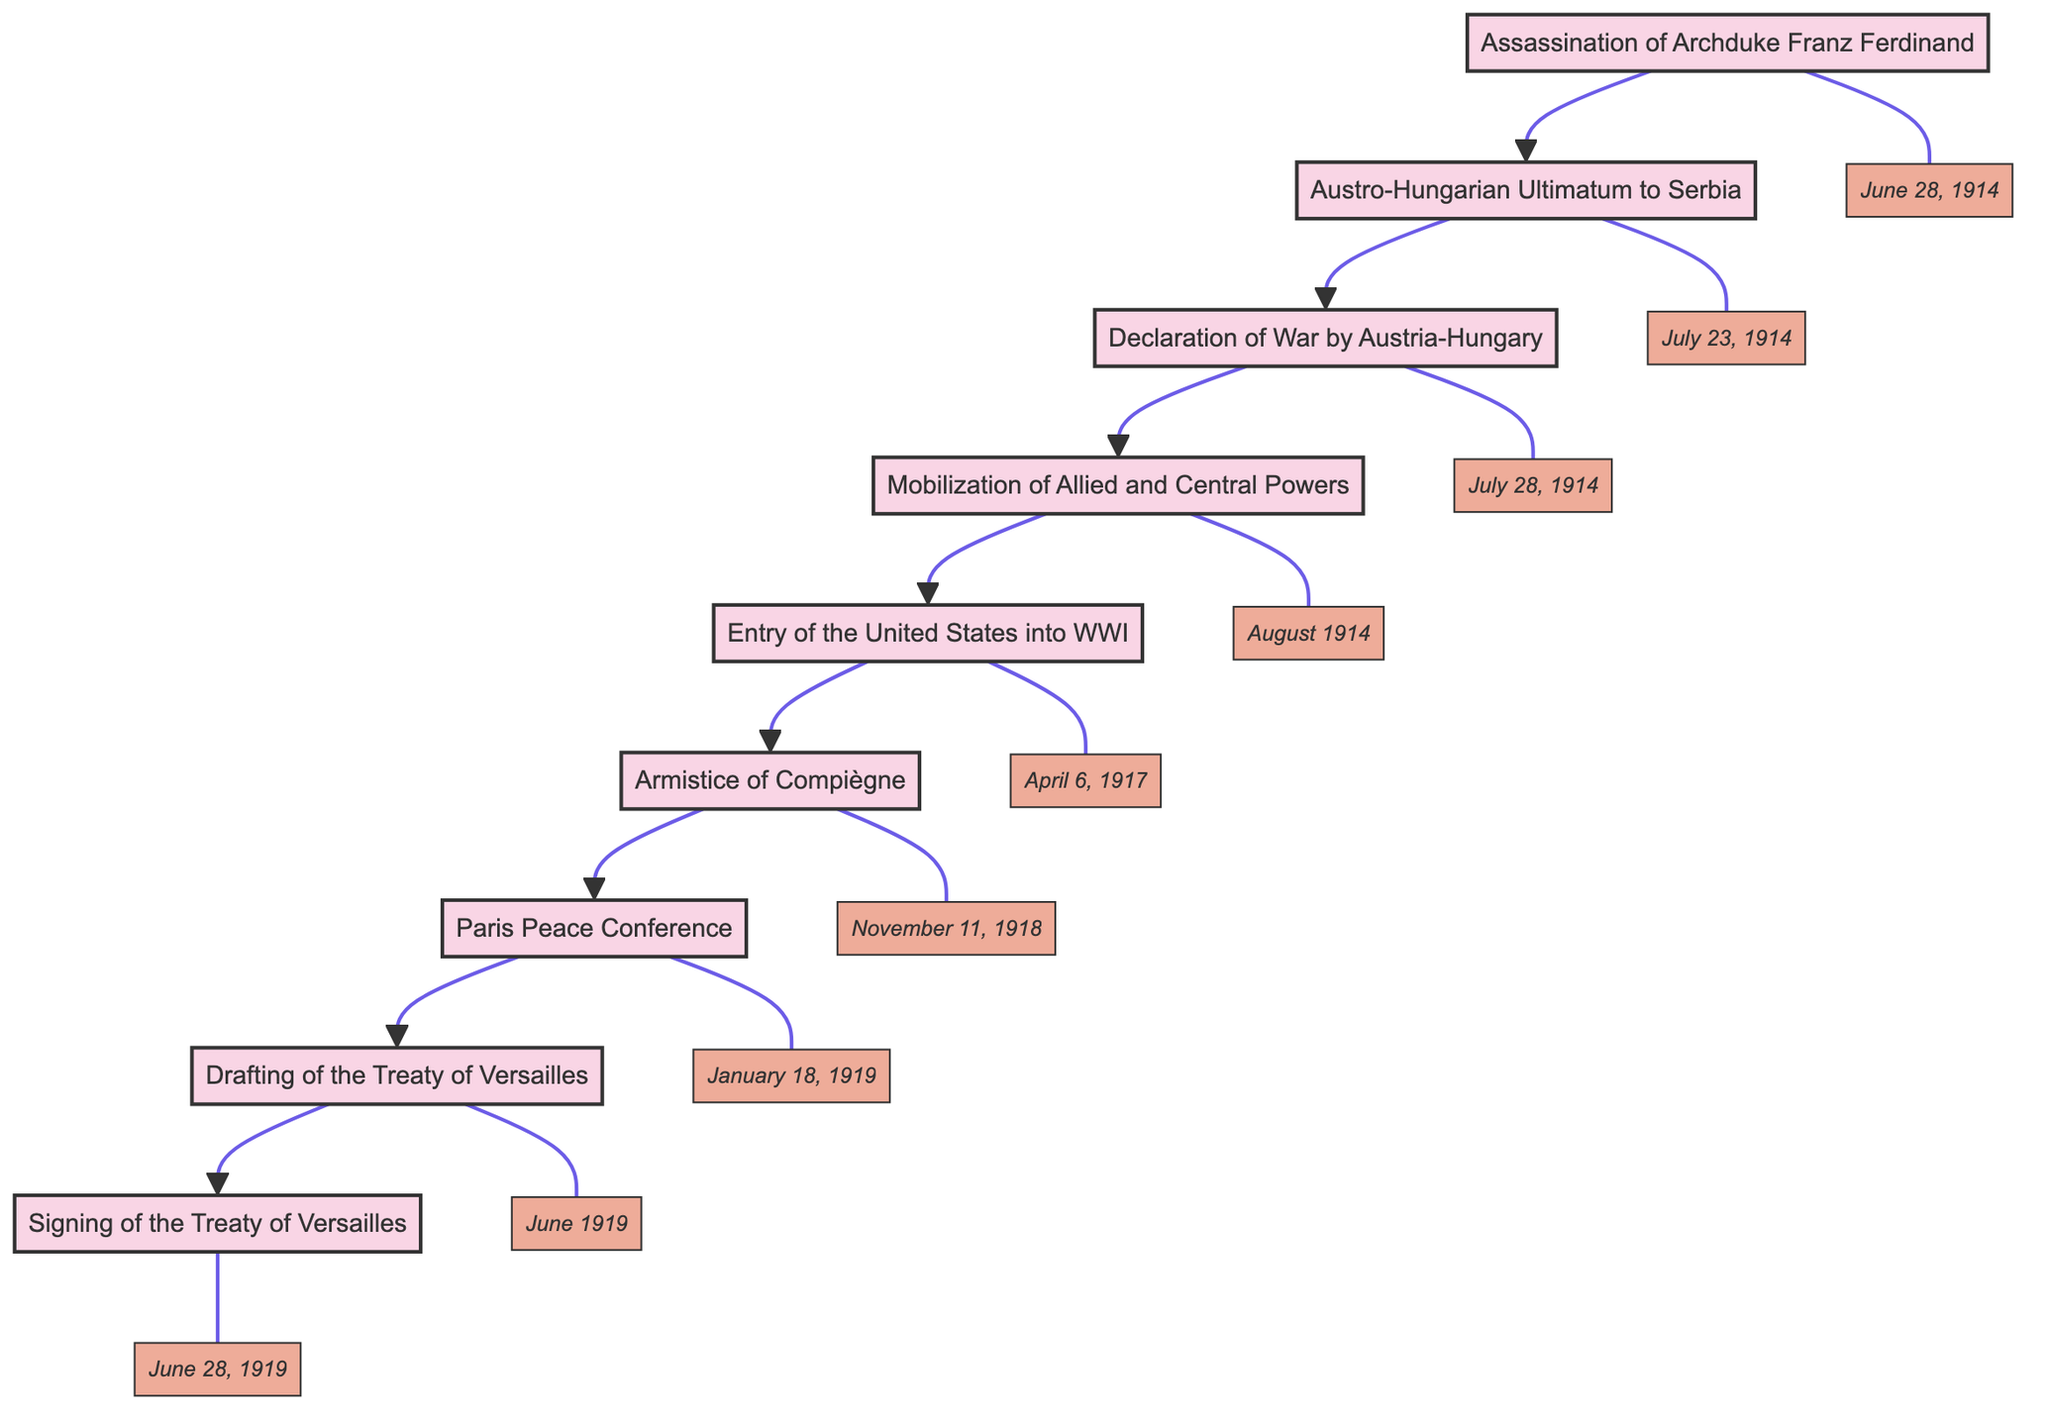What event triggers the Austro-Hungarian Ultimatum to Serbia? The diagram indicates that the event leading to the Austro-Hungarian Ultimatum is the "Assassination of Archduke Franz Ferdinand" which occurs on June 28, 1914. This event is the initial spark that escalates tensions.
Answer: Assassination of Archduke Franz Ferdinand What date marks the Signing of the Treaty of Versailles? According to the diagram, the Signing of the Treaty of Versailles takes place on June 28, 1919. It is indicated as the last event in the sequence and its specific date is listed.
Answer: June 28, 1919 How many major nodes are in the flowchart? By counting each unique event in the flowchart, we find that there are a total of 9 major nodes. These include all significant events leading up to the Treaty of Versailles.
Answer: 9 What event follows the Armistice of Compiègne? The flowchart shows that after the "Armistice of Compiègne" on November 11, 1918, the next event is the "Paris Peace Conference," which commences on January 18, 1919.
Answer: Paris Peace Conference Which event marks the United States’ involvement in World War I? The diagram specifies that the "Entry of the United States into WWI" occurs on April 6, 1917. This is highlighted as a significant turning point in the war where the US joins the Allies.
Answer: Entry of the United States into WWI What is the main focus of the Drafting of the Treaty of Versailles? The flowchart states that the primary objective during the "Drafting of the Treaty of Versailles" in June 1919 is centered around "reparations and territorial changes." This provides insight into the treaty's intentions.
Answer: Reparations and territorial changes What is the relationship between the Declaration of War by Austria-Hungary and the Mobilization of Allied and Central Powers? The flowchart clearly shows that after the "Declaration of War by Austria-Hungary" on July 28, 1914, the "Mobilization of Allied and Central Powers" follows in August 1914, indicating a sequence of escalating military actions.
Answer: Sequential relationship What key event occurs immediately before the Treaty of Versailles is signed? The diagram indicates that prior to the "Signing of the Treaty of Versailles," the event that occurs is the "Drafting of the Treaty of Versailles" in June 1919. This drafting process is crucial before the final signing.
Answer: Drafting of the Treaty of Versailles Which event serves as a precursor to the Paris Peace Conference? From the flowchart analysis, it is evident that the "Armistice of Compiègne" serves as a direct precursor to the "Paris Peace Conference." This event represents the pause in hostilities that allows for peace negotiations to commence.
Answer: Armistice of Compiègne 